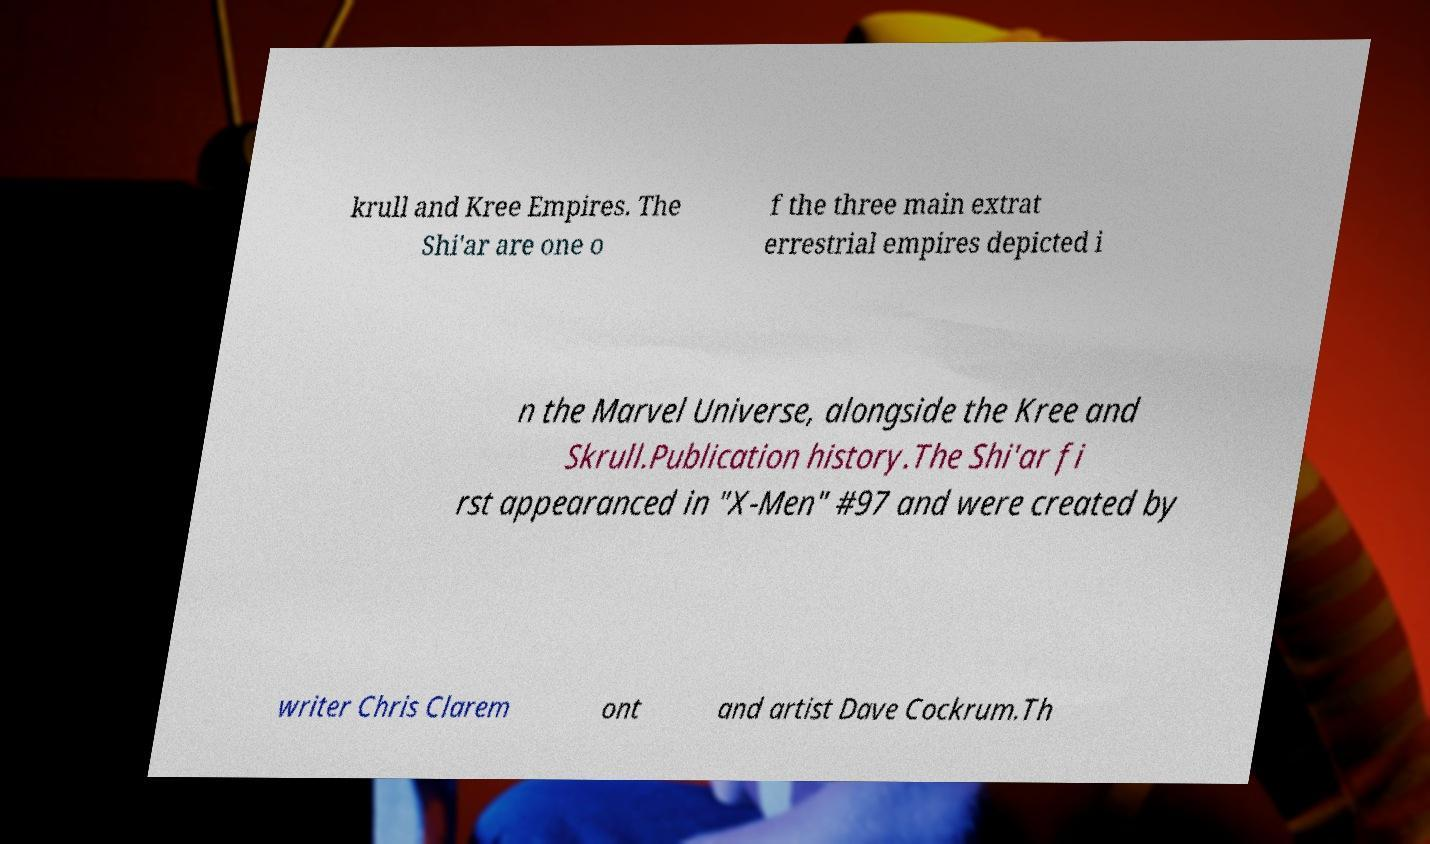Could you extract and type out the text from this image? krull and Kree Empires. The Shi'ar are one o f the three main extrat errestrial empires depicted i n the Marvel Universe, alongside the Kree and Skrull.Publication history.The Shi'ar fi rst appearanced in "X-Men" #97 and were created by writer Chris Clarem ont and artist Dave Cockrum.Th 